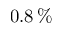<formula> <loc_0><loc_0><loc_500><loc_500>0 . 8 \, \%</formula> 